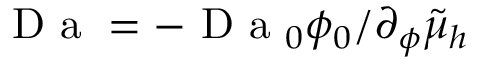Convert formula to latex. <formula><loc_0><loc_0><loc_500><loc_500>D a = - D a _ { 0 } \phi _ { 0 } / \partial _ { \phi } \tilde { \mu } _ { h }</formula> 